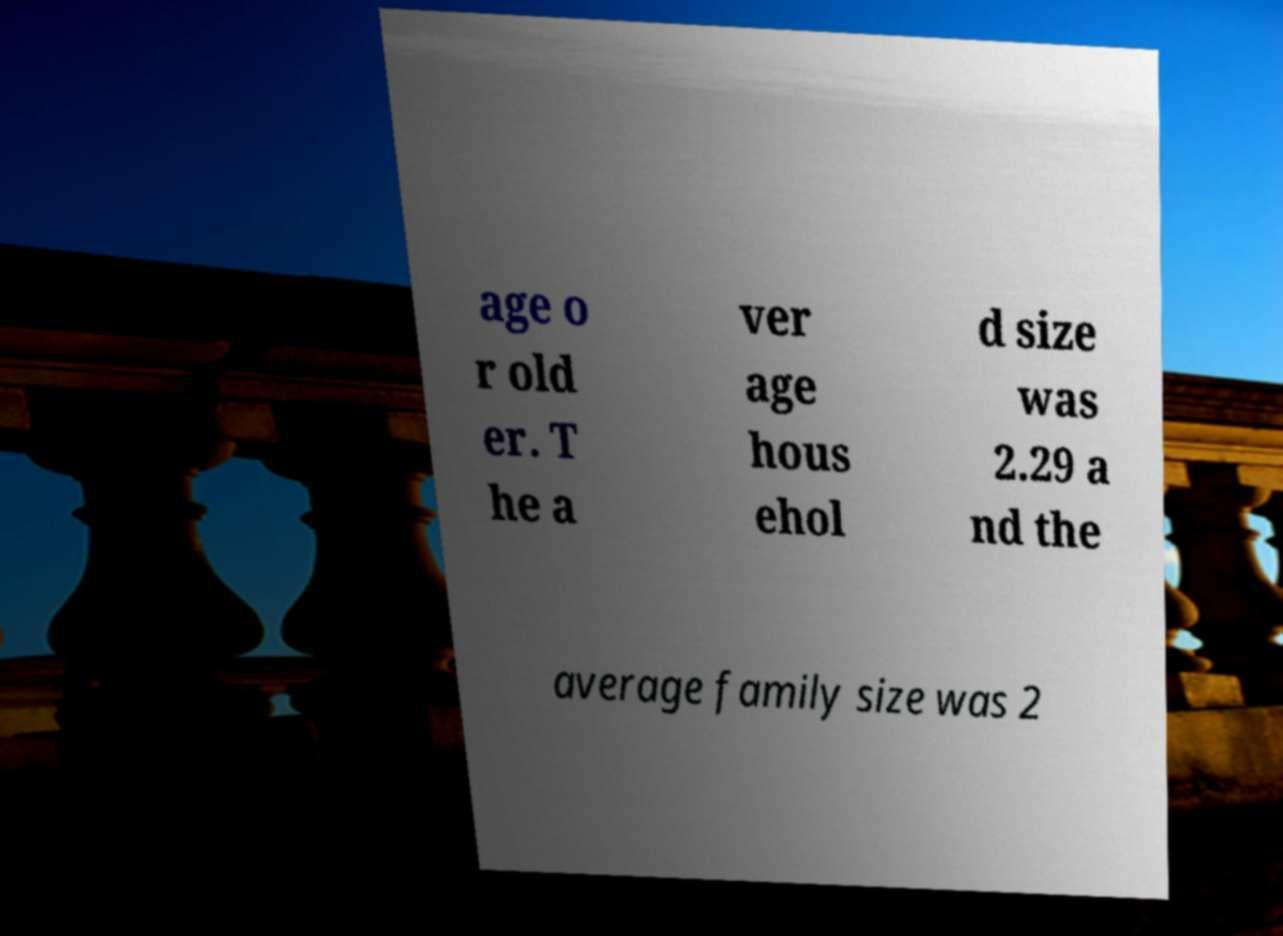There's text embedded in this image that I need extracted. Can you transcribe it verbatim? age o r old er. T he a ver age hous ehol d size was 2.29 a nd the average family size was 2 